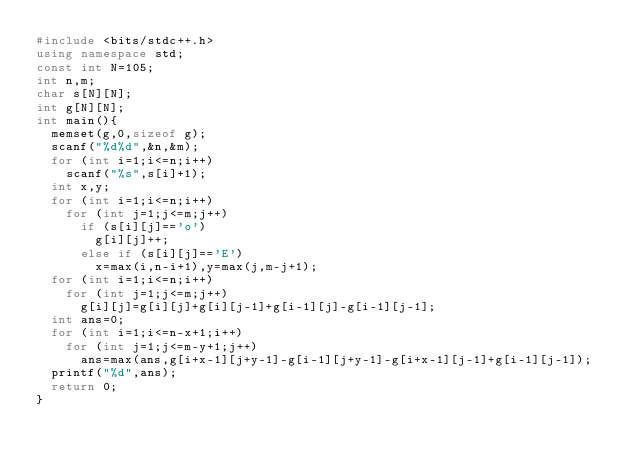<code> <loc_0><loc_0><loc_500><loc_500><_C++_>#include <bits/stdc++.h>
using namespace std;
const int N=105;
int n,m;
char s[N][N];
int g[N][N];
int main(){
	memset(g,0,sizeof g);
	scanf("%d%d",&n,&m);
	for (int i=1;i<=n;i++)
		scanf("%s",s[i]+1);
	int x,y;
	for (int i=1;i<=n;i++)
		for (int j=1;j<=m;j++)
			if (s[i][j]=='o')
				g[i][j]++;
			else if (s[i][j]=='E')
				x=max(i,n-i+1),y=max(j,m-j+1);
	for (int i=1;i<=n;i++)
		for (int j=1;j<=m;j++)
			g[i][j]=g[i][j]+g[i][j-1]+g[i-1][j]-g[i-1][j-1];
	int ans=0;
	for (int i=1;i<=n-x+1;i++)
		for (int j=1;j<=m-y+1;j++)
			ans=max(ans,g[i+x-1][j+y-1]-g[i-1][j+y-1]-g[i+x-1][j-1]+g[i-1][j-1]);
	printf("%d",ans);
	return 0;
}</code> 